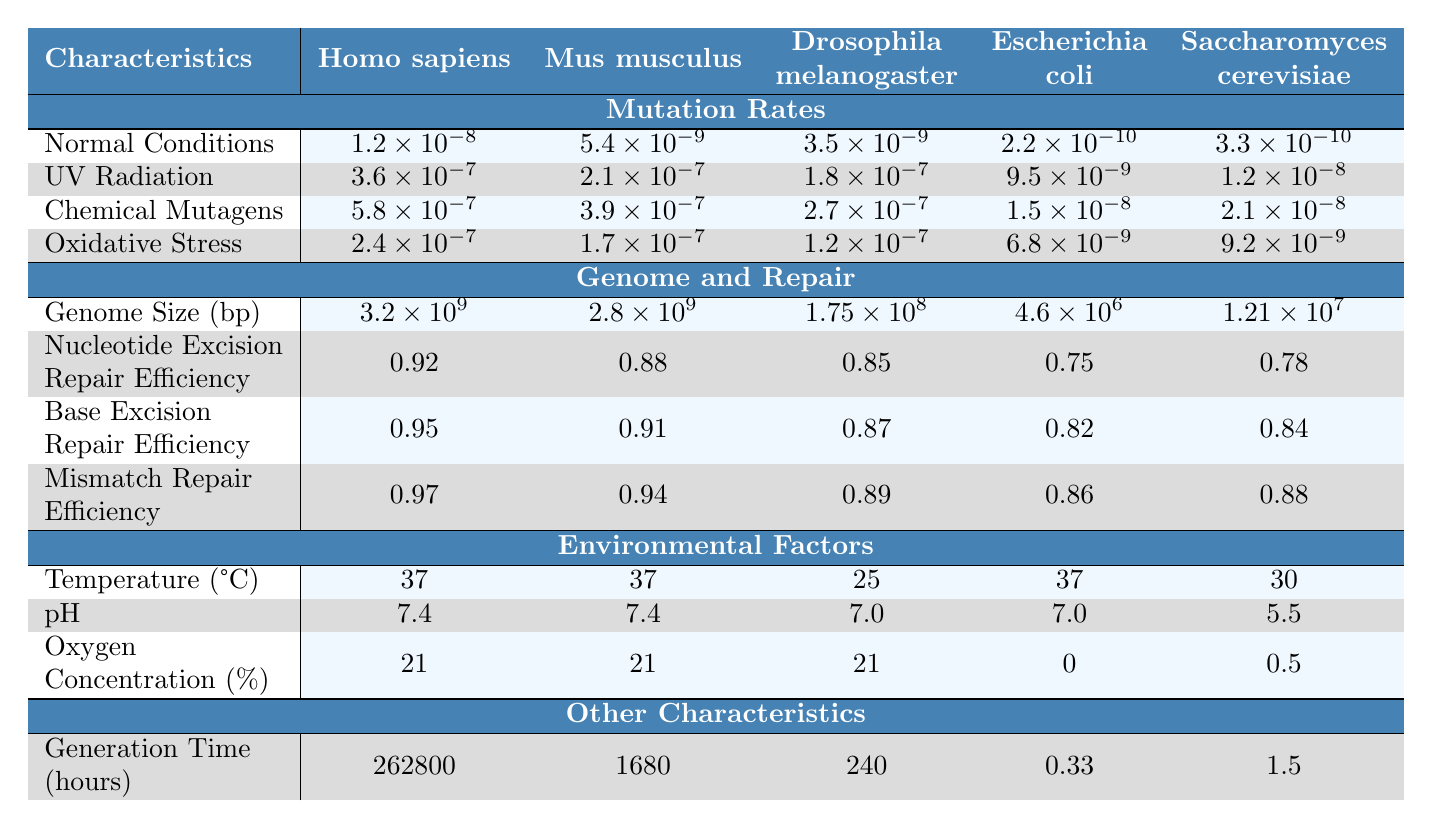What is the mutation rate for Homo sapiens under normal conditions? The table shows that the mutation rate for Homo sapiens under normal conditions is listed as 1.2e-8.
Answer: 1.2e-8 Which species has the highest mutation rate when exposed to chemical mutagens? According to the table, Homo sapiens has the highest mutation rate under chemical mutagens at 5.8e-7.
Answer: Homo sapiens What is the difference in mutation rates between normal conditions and UV radiation for Mus musculus? Mus musculus shows a mutation rate of 5.4e-9 under normal conditions and 2.1e-7 under UV radiation. The difference is 2.1e-7 - 5.4e-9 = 2.046e-7.
Answer: 2.046e-7 What is the average generation time across the species in hours? The generation times for the species are 262800, 1680, 240, 0.33, and 1.5 hours. The sum of these times is 264723.83, and dividing by 5 gives an average of 52944.766.
Answer: 52944.766 True or false: Saccharomyces cerevisiae has a mutation rate in normal conditions that is lower than that of Escherichia coli. In normal conditions, Saccharomyces cerevisiae has a mutation rate of 3.3e-10, while Escherichia coli has 2.2e-10. Since 3.3e-10 > 2.2e-10, the statement is false.
Answer: False Which environmental factor is listed for Homo sapiens and Mus musculus? Both Homo sapiens and Mus musculus have a temperature of 37 degrees Celsius as noted in the environmental factors section.
Answer: 37 degrees Celsius Under what condition does Drosophila melanogaster experience the lowest mutation rate? The table indicates that under normal conditions, Drosophila melanogaster has a mutation rate of 3.5e-9, which is lower than its rates under UV radiation (1.8e-7), chemical mutagens (2.7e-7), and oxidative stress (1.2e-7).
Answer: Normal conditions What is the repair efficiency for base excision repair in Escherichia coli? The table shows that the repair efficiency for base excision repair in Escherichia coli is 0.82.
Answer: 0.82 What is the total genome size (in base pairs) of all the species combined? The genome sizes are 3.2e9 (Homo sapiens), 2.8e9 (Mus musculus), 1.75e8 (Drosophila melanogaster), 4.6e6 (Escherichia coli), and 1.21e7 (Saccharomyces cerevisiae). The total is 3.2e9 + 2.8e9 + 1.75e8 + 4.6e6 + 1.21e7 = 5.08034e9.
Answer: 5.08034e9 Which species has the lowest oxygen concentration percentage in the environment according to the table? The data shows that Escherichia coli and Saccharomyces cerevisiae have lower oxygen concentration percentages at 0% and 0.5%, respectively. Therefore, Escherichia coli has the lowest.
Answer: Escherichia coli 